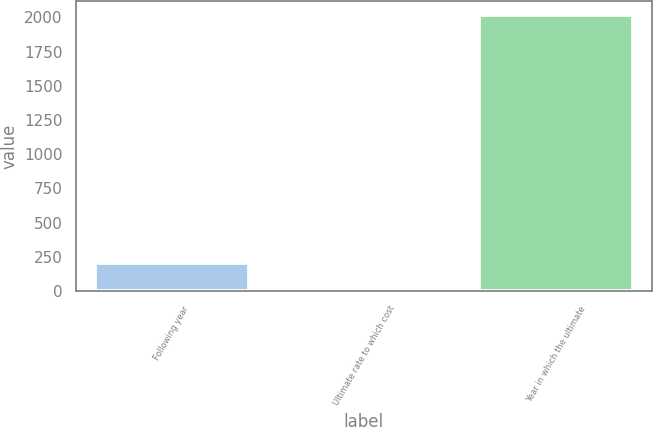Convert chart to OTSL. <chart><loc_0><loc_0><loc_500><loc_500><bar_chart><fcel>Following year<fcel>Ultimate rate to which cost<fcel>Year in which the ultimate<nl><fcel>206.5<fcel>5<fcel>2020<nl></chart> 